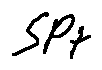<formula> <loc_0><loc_0><loc_500><loc_500>s p _ { t }</formula> 